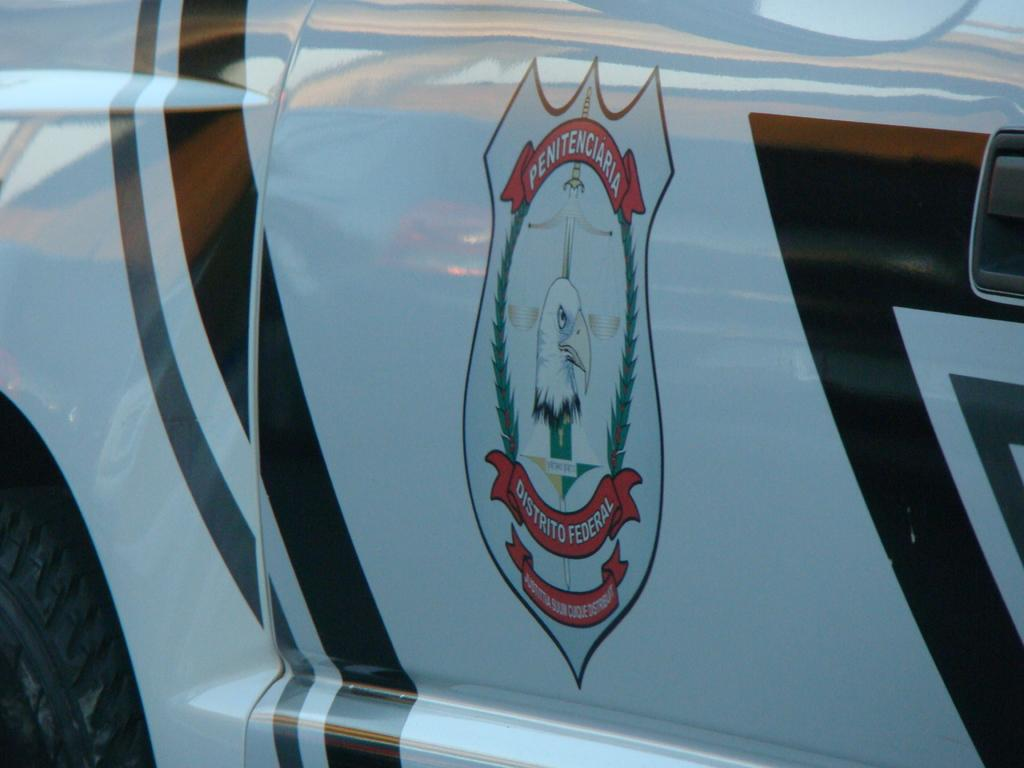What is the main subject of the picture? The main subject of the picture is a vehicle. Can you describe any specific features of the vehicle? Yes, the vehicle has a logo painted on it. Where is the father sleeping in the image? There is no father or bed present in the image, so it cannot be determined where someone might be sleeping. 